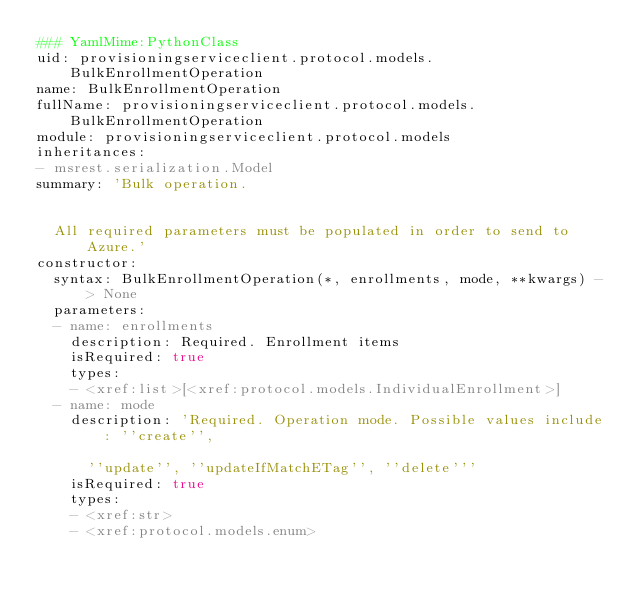<code> <loc_0><loc_0><loc_500><loc_500><_YAML_>### YamlMime:PythonClass
uid: provisioningserviceclient.protocol.models.BulkEnrollmentOperation
name: BulkEnrollmentOperation
fullName: provisioningserviceclient.protocol.models.BulkEnrollmentOperation
module: provisioningserviceclient.protocol.models
inheritances:
- msrest.serialization.Model
summary: 'Bulk operation.


  All required parameters must be populated in order to send to Azure.'
constructor:
  syntax: BulkEnrollmentOperation(*, enrollments, mode, **kwargs) -> None
  parameters:
  - name: enrollments
    description: Required. Enrollment items
    isRequired: true
    types:
    - <xref:list>[<xref:protocol.models.IndividualEnrollment>]
  - name: mode
    description: 'Required. Operation mode. Possible values include: ''create'',

      ''update'', ''updateIfMatchETag'', ''delete'''
    isRequired: true
    types:
    - <xref:str>
    - <xref:protocol.models.enum>
</code> 